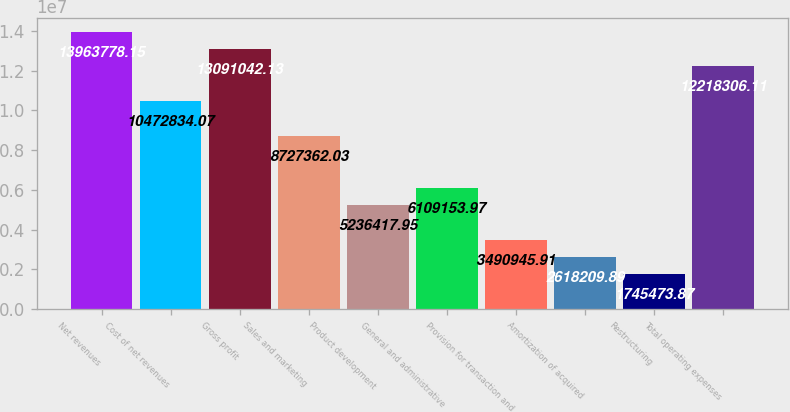Convert chart to OTSL. <chart><loc_0><loc_0><loc_500><loc_500><bar_chart><fcel>Net revenues<fcel>Cost of net revenues<fcel>Gross profit<fcel>Sales and marketing<fcel>Product development<fcel>General and administrative<fcel>Provision for transaction and<fcel>Amortization of acquired<fcel>Restructuring<fcel>Total operating expenses<nl><fcel>1.39638e+07<fcel>1.04728e+07<fcel>1.3091e+07<fcel>8.72736e+06<fcel>5.23642e+06<fcel>6.10915e+06<fcel>3.49095e+06<fcel>2.61821e+06<fcel>1.74547e+06<fcel>1.22183e+07<nl></chart> 